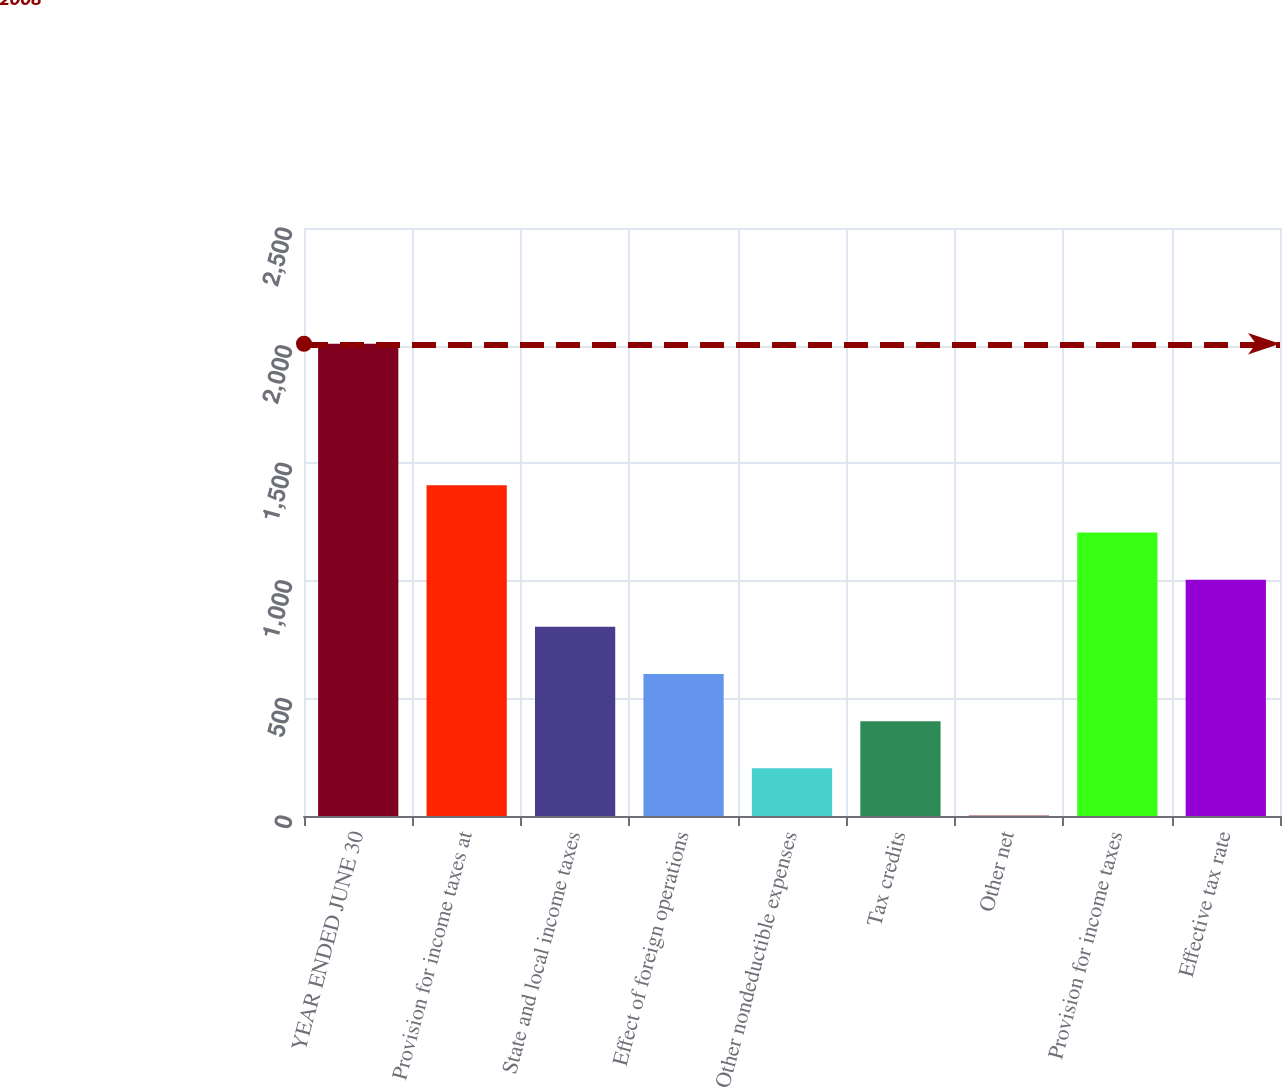Convert chart. <chart><loc_0><loc_0><loc_500><loc_500><bar_chart><fcel>YEAR ENDED JUNE 30<fcel>Provision for income taxes at<fcel>State and local income taxes<fcel>Effect of foreign operations<fcel>Other nondeductible expenses<fcel>Tax credits<fcel>Other net<fcel>Provision for income taxes<fcel>Effective tax rate<nl><fcel>2008<fcel>1406.17<fcel>804.34<fcel>603.73<fcel>202.51<fcel>403.12<fcel>1.9<fcel>1205.56<fcel>1004.95<nl></chart> 